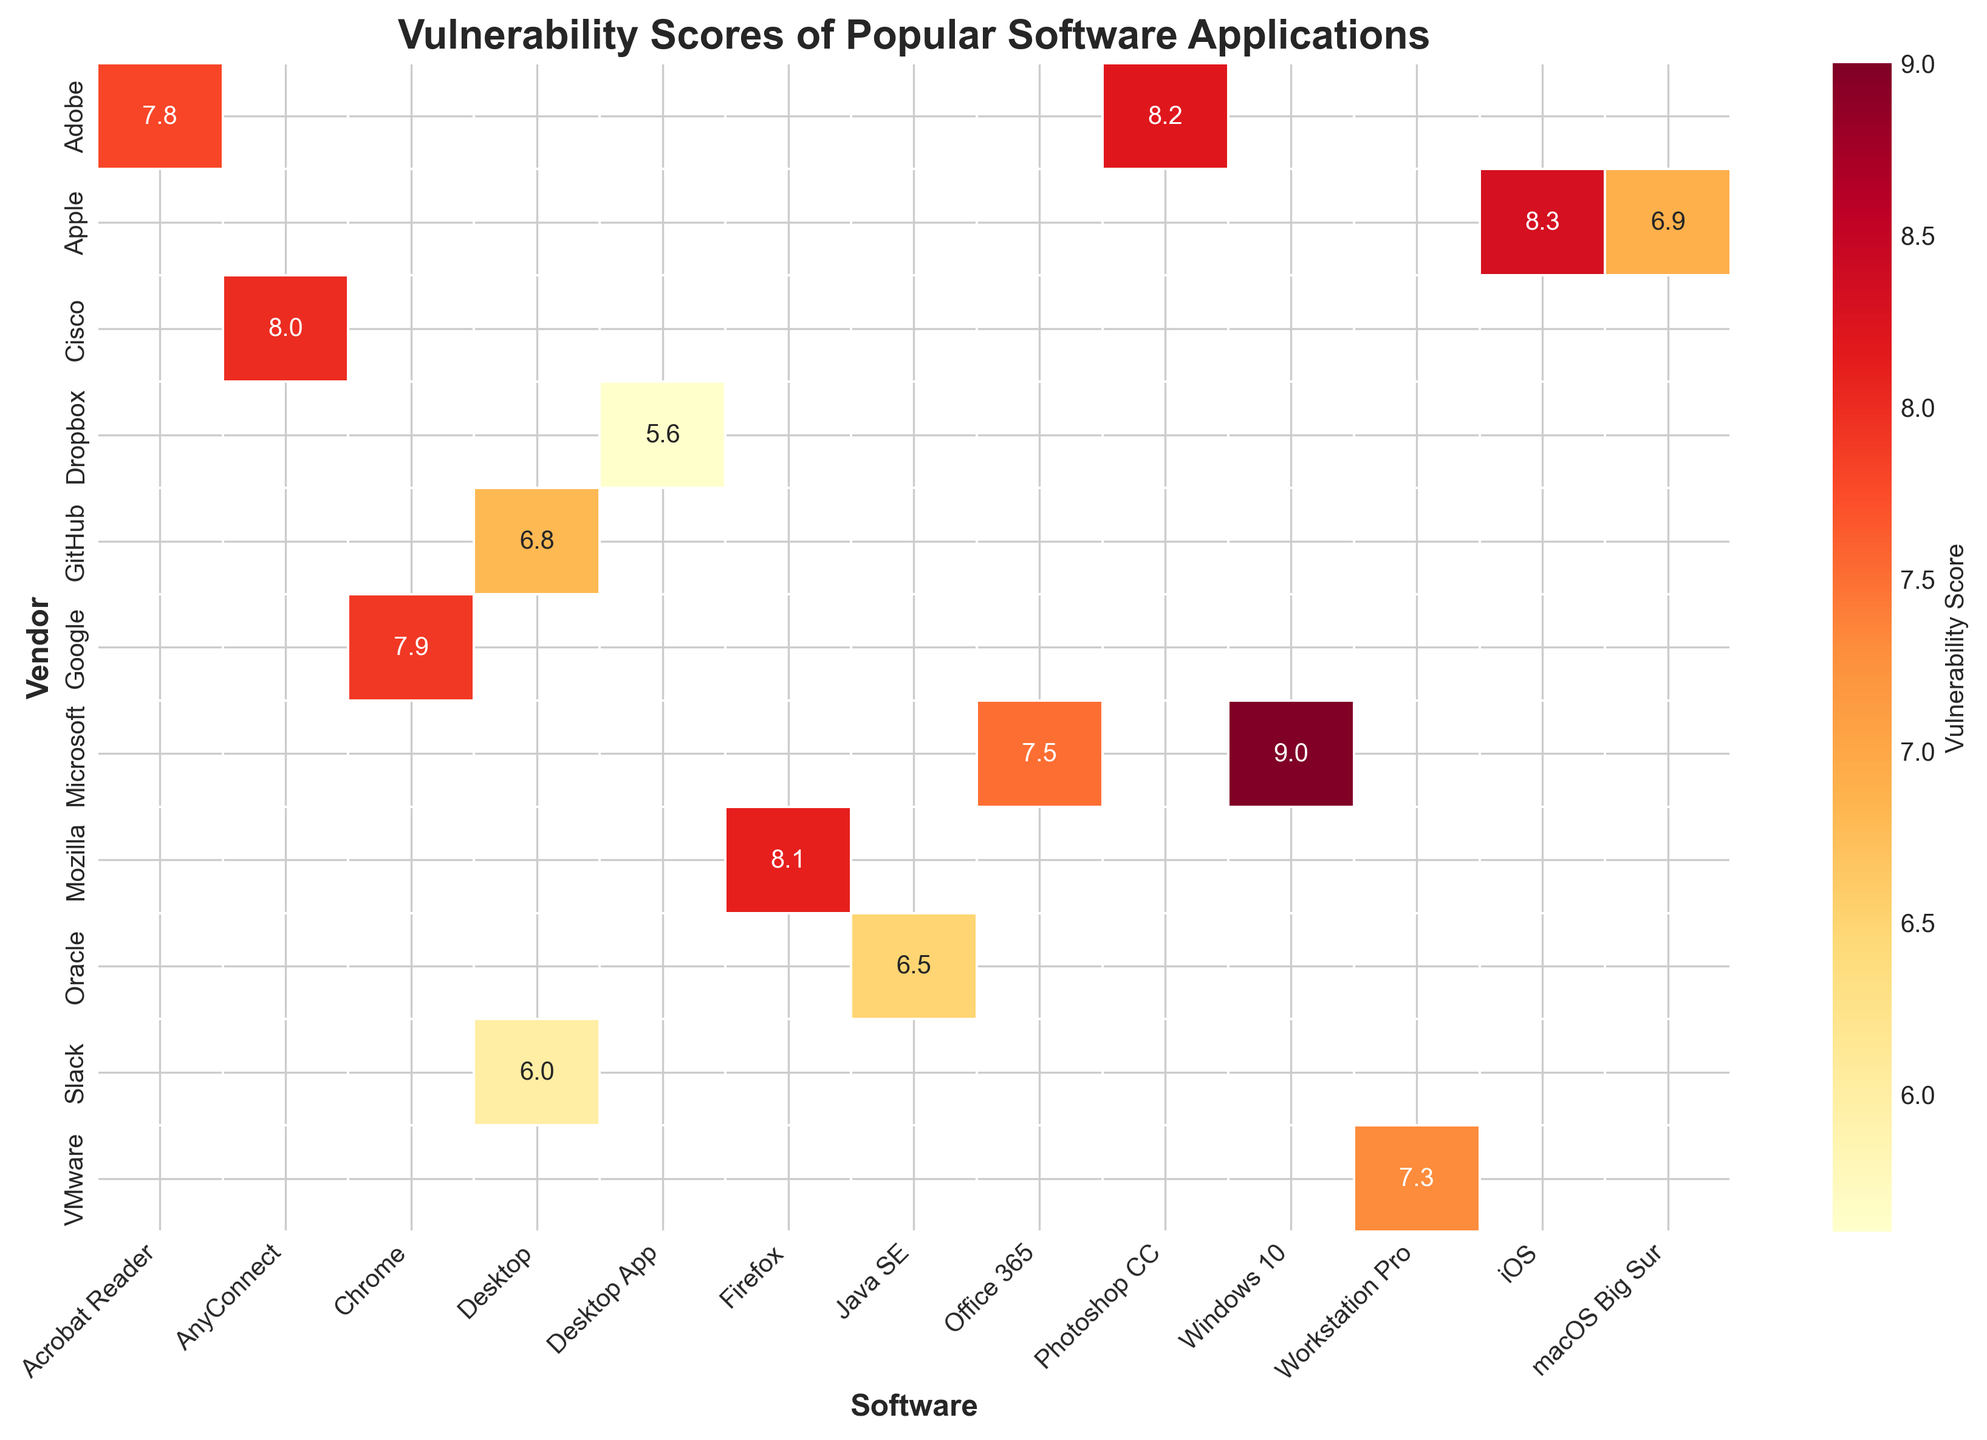What's the title of the figure? To find the title, look at the top of the figure where titles are usually placed. The title for this heatmap is "Vulnerability Scores of Popular Software Applications".
Answer: Vulnerability Scores of Popular Software Applications Which vendor has the software version with the highest vulnerability score? Identify the maximum value in the heatmap and find the corresponding row (vendor). The highest vulnerability score is 9.0, which belongs to Microsoft.
Answer: Microsoft How many vendors have vulnerability scores equal to or greater than 8.0 for any of their software? Count all the values in the heatmap that are equal to or greater than 8.0 and then count the unique vendors for those values. There are five such vendors: Adobe, Microsoft, Apple, Mozilla, and Cisco.
Answer: Five Which software has the lowest vulnerability score, and what is its value? Identify the minimum value in the heatmap and find the corresponding software. The lowest vulnerability score is 5.6, which belongs to Dropbox Desktop App.
Answer: Dropbox Desktop App, 5.6 What is the average vulnerability score for Adobe's software? Add the vulnerability scores of all Adobe software (7.8 + 8.2) and divide by the number of Adobe software entries. (7.8 + 8.2) / 2 = 8.0
Answer: 8.0 Compare the vulnerability scores of Google's Chrome and Mozilla's Firefox. Which one has a higher score? Locate the scores for Chrome (7.9) and Firefox (8.1), then compare them. Firefox has a higher score.
Answer: Firefox Which version of Apple's software has a higher vulnerability score, macOS Big Sur or iOS? Compare the vulnerability scores for macOS Big Sur (6.9) and iOS (8.3). iOS has a higher score.
Answer: iOS What is the range of vulnerability scores for the software in the heatmap? Identify the highest value (9.0) and the lowest value (5.6). The range is the difference between the highest and lowest values: 9.0 - 5.6 = 3.4
Answer: 3.4 Sum the vulnerability scores for all the software versions provided by Microsoft. What is the total? Add the vulnerability scores for Microsoft Windows 10 (9.0) and Microsoft Office 365 (7.5). 9.0 + 7.5 = 16.5
Answer: 16.5 